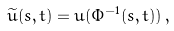Convert formula to latex. <formula><loc_0><loc_0><loc_500><loc_500>\widetilde { u } ( s , t ) = u ( \Phi ^ { - 1 } ( s , t ) ) \, ,</formula> 